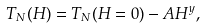Convert formula to latex. <formula><loc_0><loc_0><loc_500><loc_500>T _ { N } ( H ) = T _ { N } ( H = 0 ) - A H ^ { y } ,</formula> 